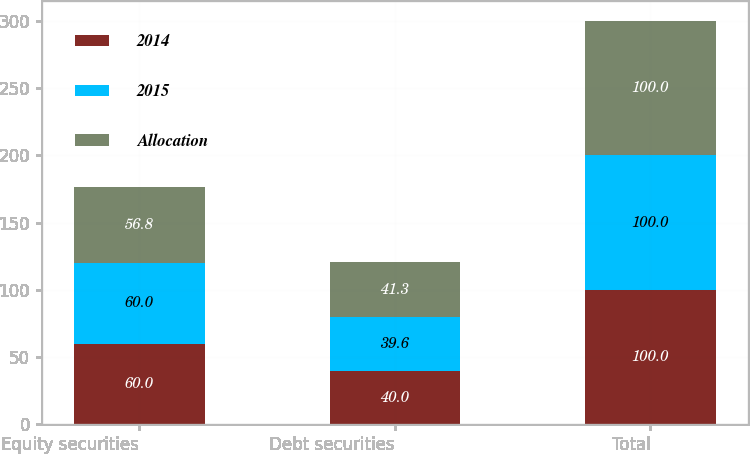Convert chart to OTSL. <chart><loc_0><loc_0><loc_500><loc_500><stacked_bar_chart><ecel><fcel>Equity securities<fcel>Debt securities<fcel>Total<nl><fcel>2014<fcel>60<fcel>40<fcel>100<nl><fcel>2015<fcel>60<fcel>39.6<fcel>100<nl><fcel>Allocation<fcel>56.8<fcel>41.3<fcel>100<nl></chart> 